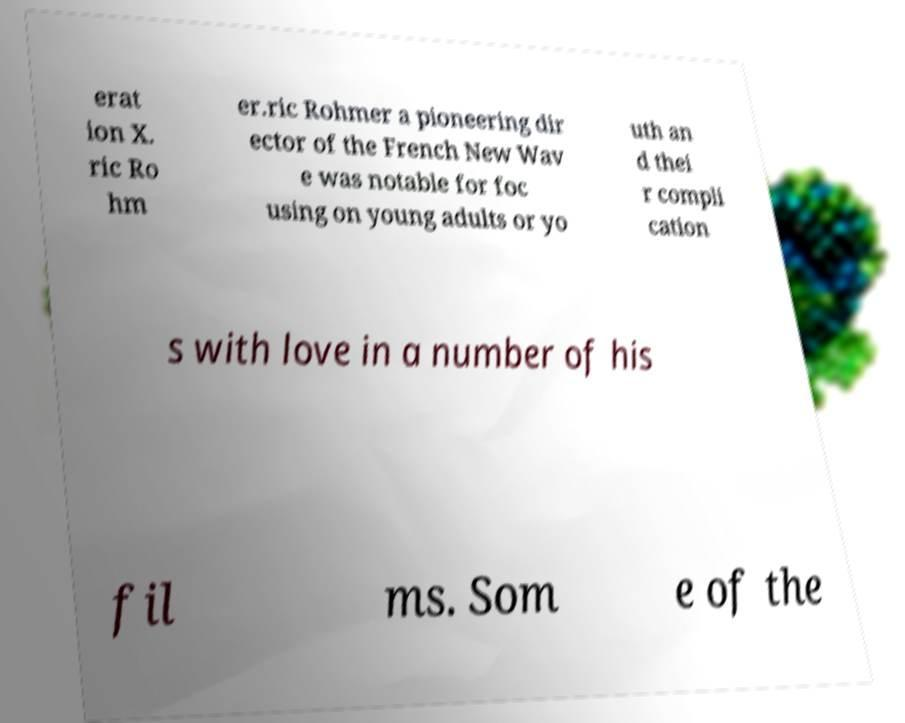Can you read and provide the text displayed in the image?This photo seems to have some interesting text. Can you extract and type it out for me? erat ion X. ric Ro hm er.ric Rohmer a pioneering dir ector of the French New Wav e was notable for foc using on young adults or yo uth an d thei r compli cation s with love in a number of his fil ms. Som e of the 